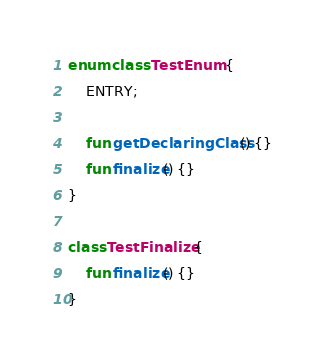Convert code to text. <code><loc_0><loc_0><loc_500><loc_500><_Kotlin_>enum class TestEnum {
    ENTRY;

    fun getDeclaringClass() {}
    fun finalize() {}
}

class TestFinalize {
    fun finalize() {}
}
</code> 